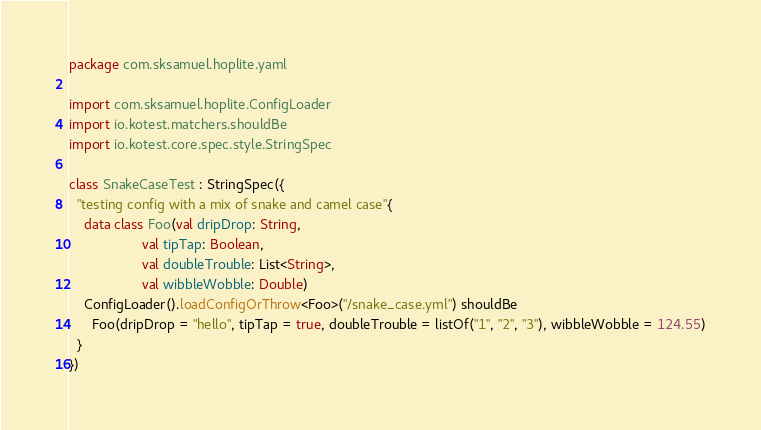<code> <loc_0><loc_0><loc_500><loc_500><_Kotlin_>package com.sksamuel.hoplite.yaml

import com.sksamuel.hoplite.ConfigLoader
import io.kotest.matchers.shouldBe
import io.kotest.core.spec.style.StringSpec

class SnakeCaseTest : StringSpec({
  "testing config with a mix of snake and camel case"{
    data class Foo(val dripDrop: String,
                   val tipTap: Boolean,
                   val doubleTrouble: List<String>,
                   val wibbleWobble: Double)
    ConfigLoader().loadConfigOrThrow<Foo>("/snake_case.yml") shouldBe
      Foo(dripDrop = "hello", tipTap = true, doubleTrouble = listOf("1", "2", "3"), wibbleWobble = 124.55)
  }
})
</code> 